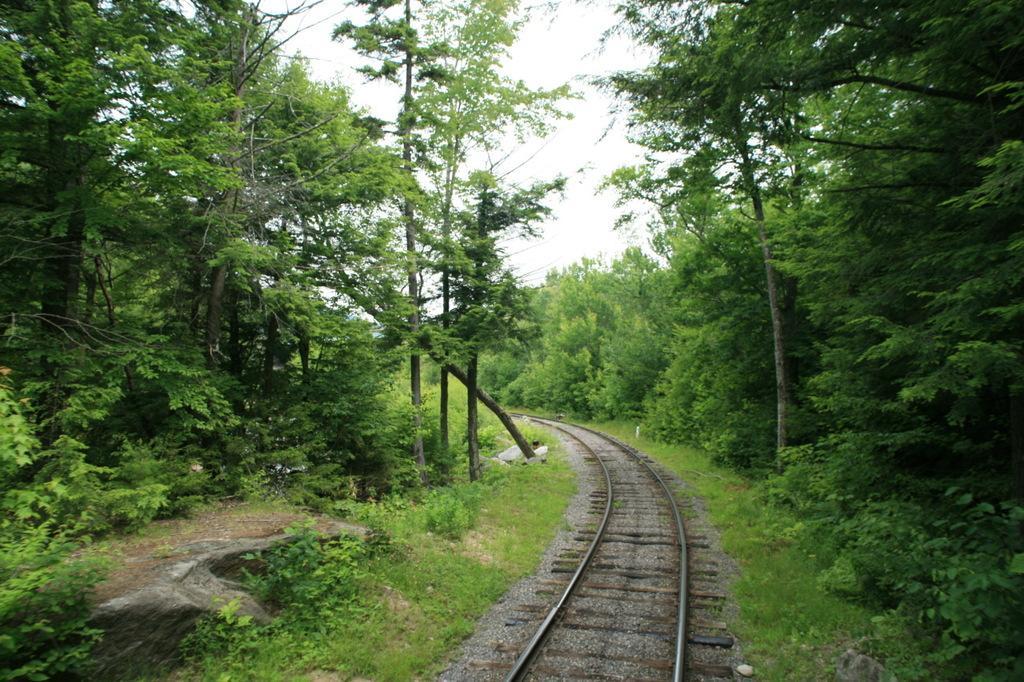Can you describe this image briefly? In this picture we can observe a railway track. There are some plants and trees on either sides of the track. In the background there is a sky. 